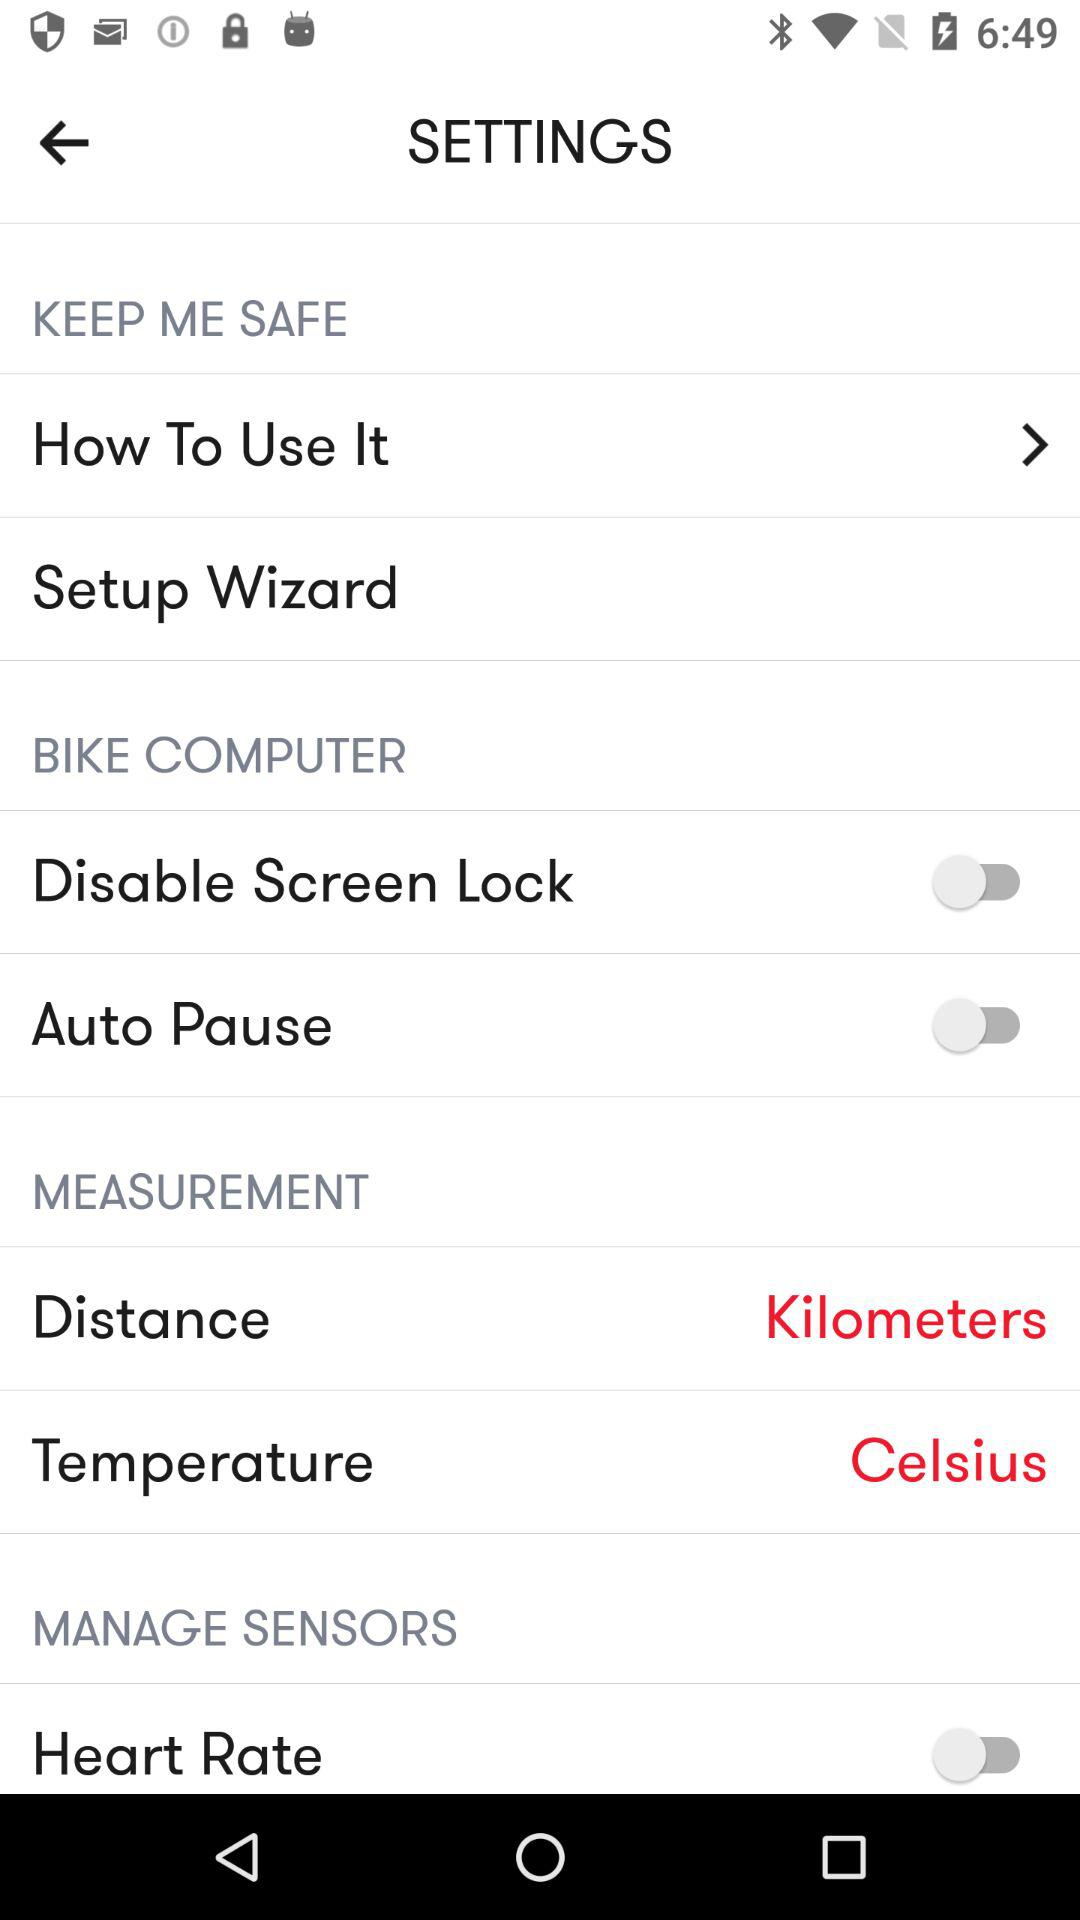What is the status of the auto pause? The status is off. 